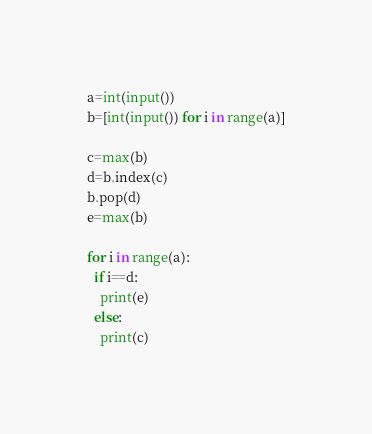<code> <loc_0><loc_0><loc_500><loc_500><_Python_>a=int(input())
b=[int(input()) for i in range(a)]

c=max(b)
d=b.index(c)
b.pop(d)
e=max(b)

for i in range(a):
  if i==d:
    print(e)
  else:
    print(c)</code> 